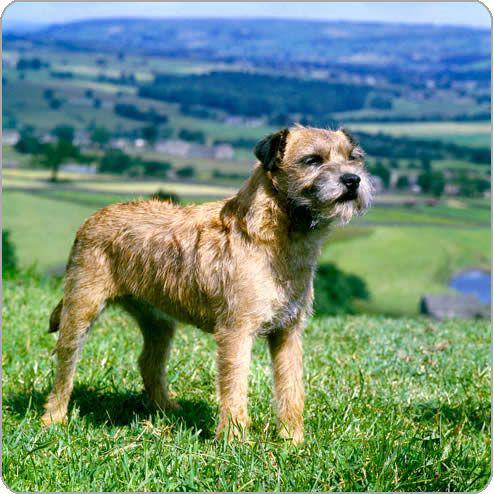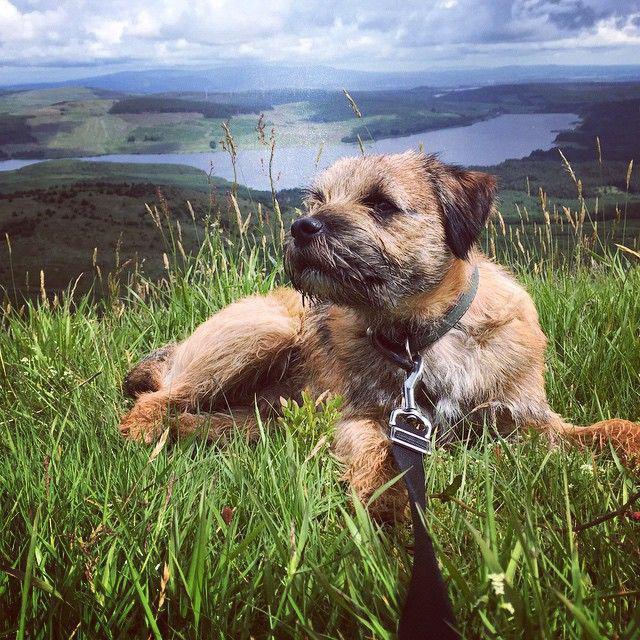The first image is the image on the left, the second image is the image on the right. Assess this claim about the two images: "The left image shows one dog with a rightward turned body standing on all fours, and the right image shows a dog looking leftward.". Correct or not? Answer yes or no. Yes. The first image is the image on the left, the second image is the image on the right. Assess this claim about the two images: "The left and right image contains the same number of dogs with at least one laying down.". Correct or not? Answer yes or no. Yes. 